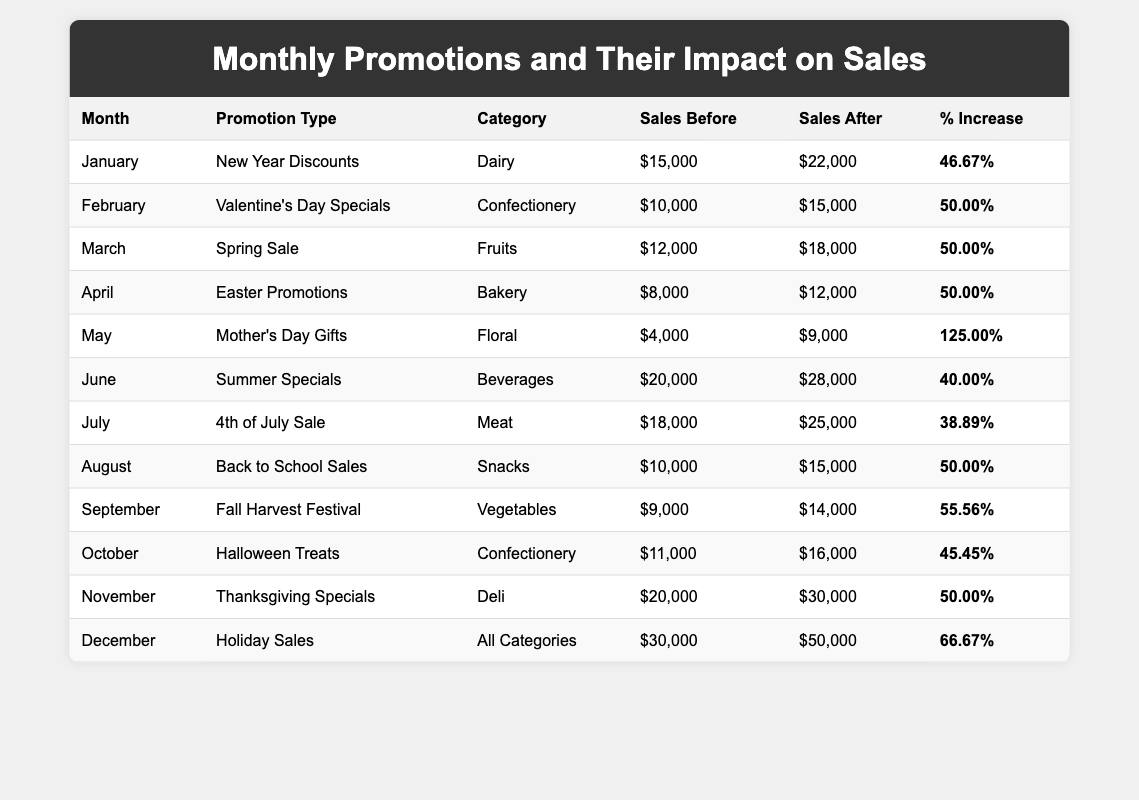What was the sales before the promotion in March? Referring to the March row in the table, the sales before the promotion is listed as $12,000.
Answer: $12,000 Which month had the highest percentage increase in sales? Looking through the percentage increase column, May shows a 125% increase, which is the highest among all months.
Answer: May What were the sales after the promotion for October? The October row indicates that the sales after the promotion reached $16,000.
Answer: $16,000 How much did sales increase in December compared to November? To find the increase, subtract November's sales after promotion ($30,000) from December's sales after promotion ($50,000), which gives us $20,000.
Answer: $20,000 Did the Spring Sale in March have the same percentage increase as Valentine's Day Specials in February? In March, the percentage increase is 50% and in February, it is also 50%, so they are the same.
Answer: Yes What category experienced a 50% increase in February and March? Both Valentine's Day Specials in February and Spring Sale in March are in the Confectionery and Fruits categories, respectively, with a 50% increase in sales.
Answer: Confectionery and Fruits What is the average sales increase percentage for the months May and June? The sales increase percentages for May and June are 125% and 40%, respectively. The average is calculated as (125 + 40) / 2, which equals 82.5%.
Answer: 82.5% Which two months had an increase of exactly $5,000 in sales after the promotion? Looking closely, August and April both show an increase of $5,000 in sales after the promotion. August's sales increased from $10,000 to $15,000, while April's sales increased from $8,000 to $12,000.
Answer: August and April Was the total sales before the promotions greater or less than $200,000? The total of sales before promotions is (15,000 + 10,000 + 12,000 + 8,000 + 4,000 + 20,000 + 18,000 + 10,000 + 9,000 + 11,000 + 20,000 + 30,000) = $ 200,000. As it equals $200,000, it is neither greater nor less.
Answer: No What is the total sales after promotions for the months of January through July? Summing the sales after promotions for the first seven months gives us (22,000 + 15,000 + 18,000 + 12,000 + 9,000 + 28,000 + 25,000) = $129,000.
Answer: $129,000 